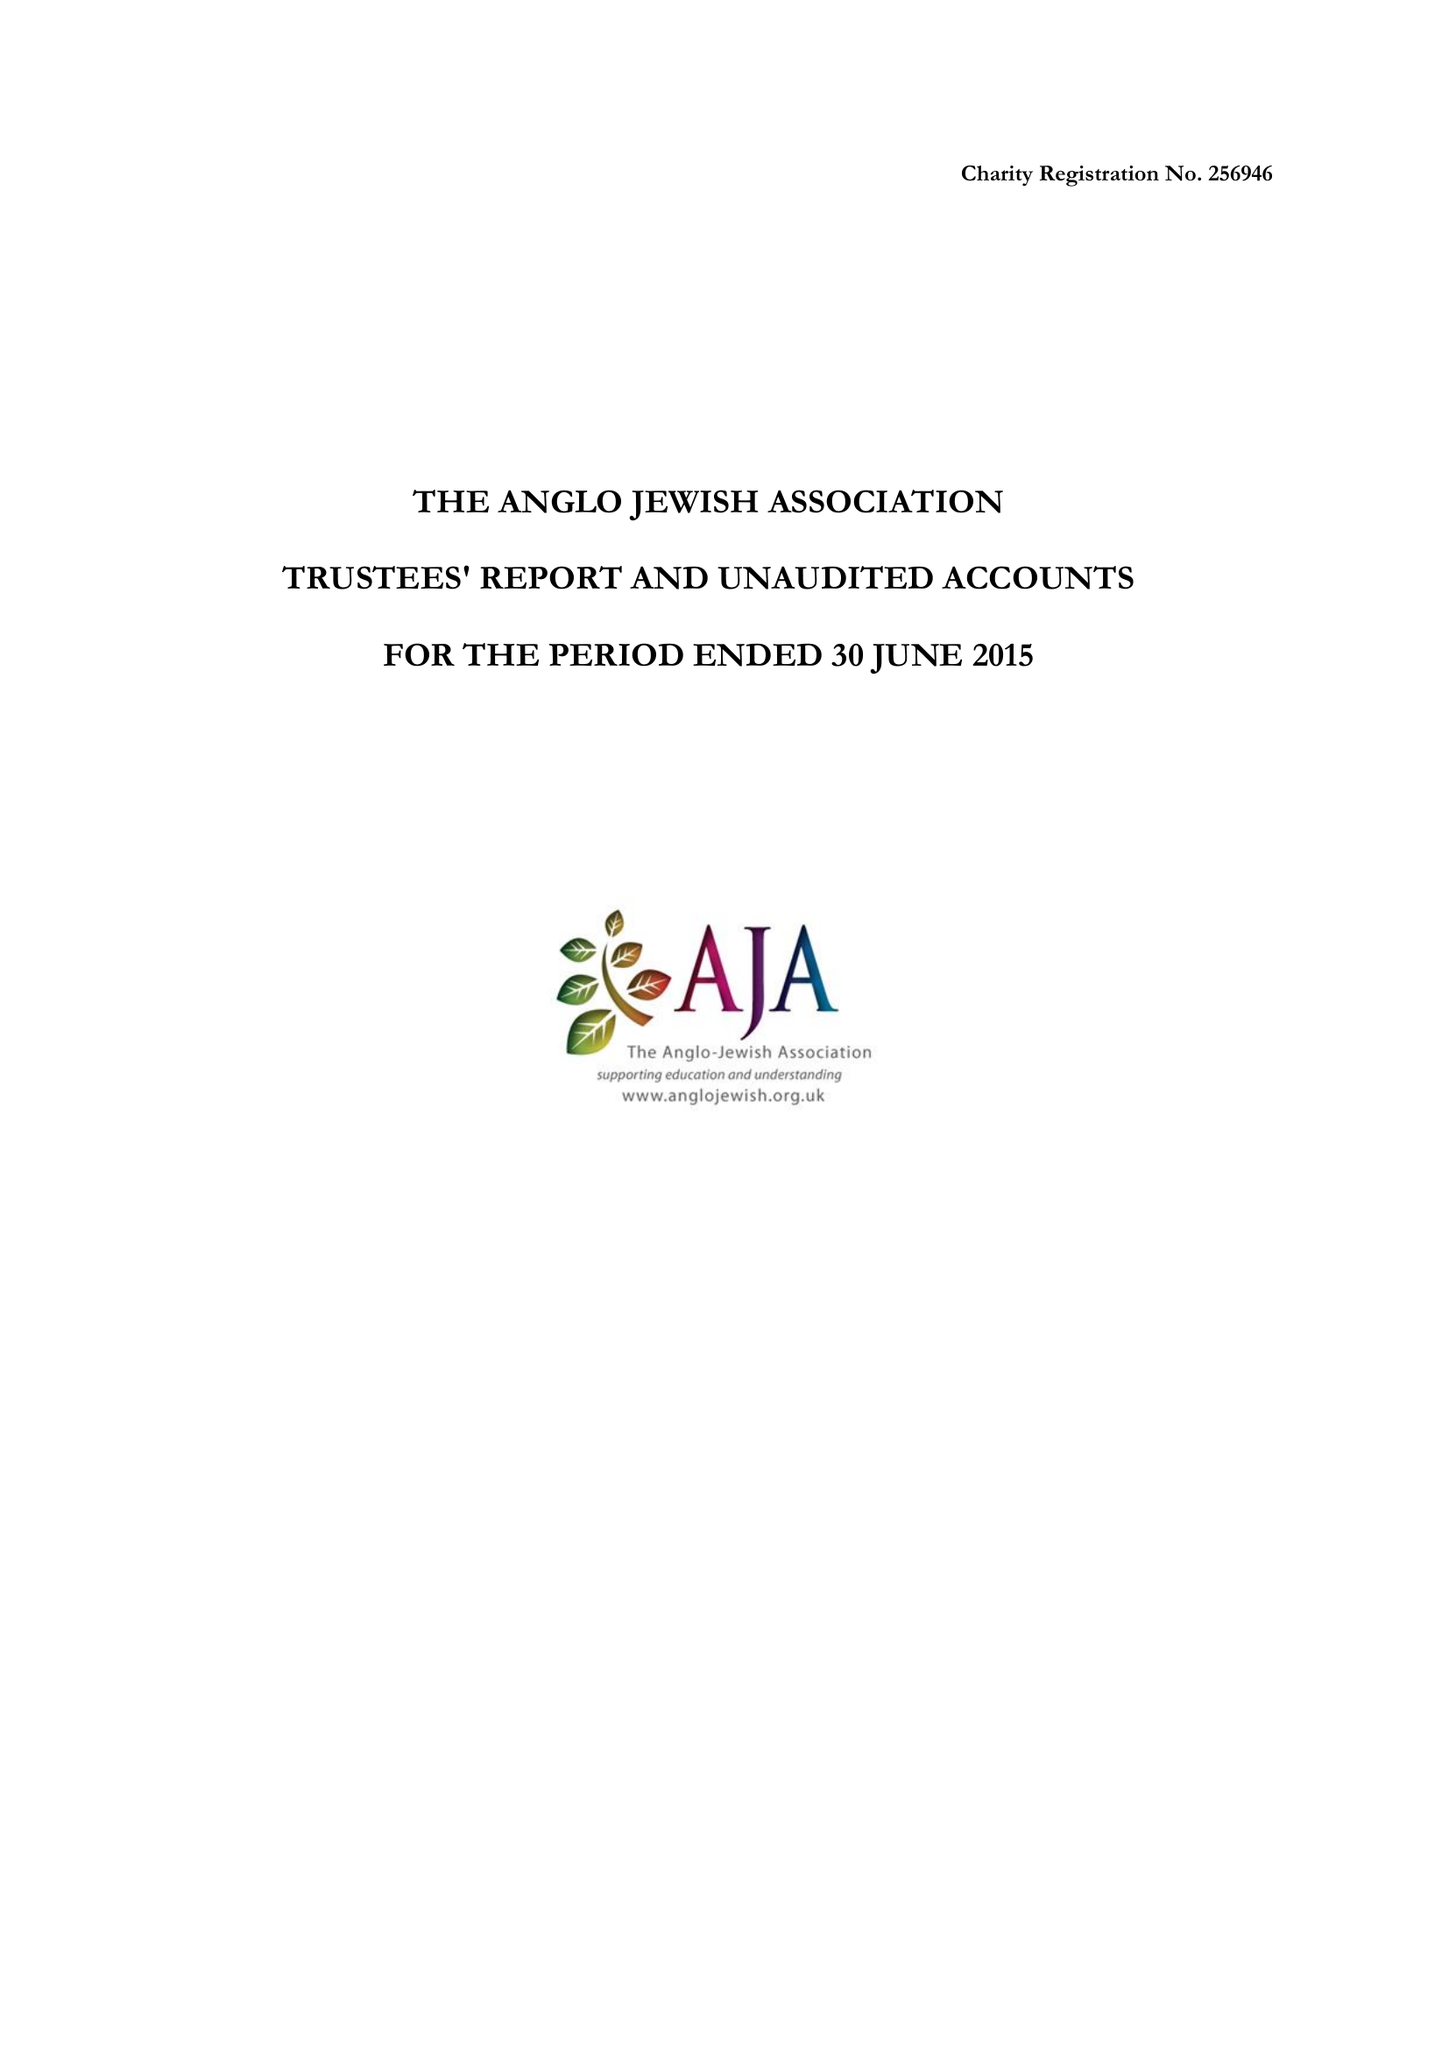What is the value for the report_date?
Answer the question using a single word or phrase. 2015-06-30 